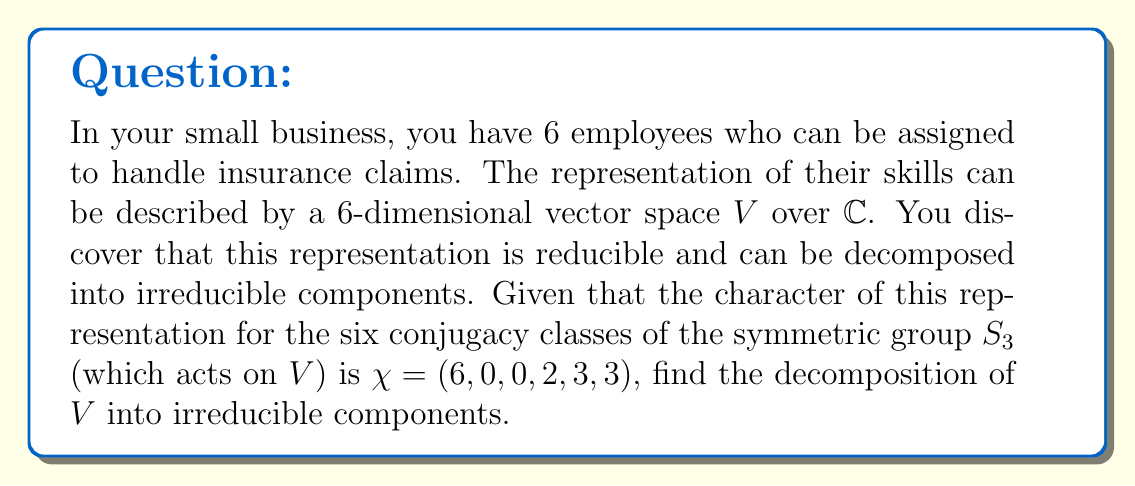Give your solution to this math problem. Let's approach this step-by-step:

1) First, recall that $S_3$ has three irreducible representations: the trivial representation ($\chi_1$), the sign representation ($\chi_2$), and a 2-dimensional representation ($\chi_3$). Their characters are:

   $\chi_1 = (1, 1, 1, 1, 1, 1)$
   $\chi_2 = (1, -1, -1, 1, 1, 1)$
   $\chi_3 = (2, 0, 0, -1, 1, 1)$

2) To find the decomposition, we need to calculate the multiplicities of each irreducible representation in $V$. We use the formula:

   $m_i = \frac{1}{|G|} \sum_{g \in G} \chi(g) \overline{\chi_i(g)}$

   where $|G| = 6$ for $S_3$.

3) For $\chi_1$:
   $m_1 = \frac{1}{6}(6 \cdot 1 + 0 \cdot 1 + 0 \cdot 1 + 2 \cdot 1 + 3 \cdot 1 + 3 \cdot 1) = \frac{14}{6} = \frac{7}{3}$

4) For $\chi_2$:
   $m_2 = \frac{1}{6}(6 \cdot 1 + 0 \cdot (-1) + 0 \cdot (-1) + 2 \cdot 1 + 3 \cdot 1 + 3 \cdot 1) = \frac{14}{6} = \frac{7}{3}$

5) For $\chi_3$:
   $m_3 = \frac{1}{6}(6 \cdot 2 + 0 \cdot 0 + 0 \cdot 0 + 2 \cdot (-1) + 3 \cdot 1 + 3 \cdot 1) = \frac{10}{6} = \frac{5}{3}$

6) The multiplicities must be integers, so we round to the nearest whole number:
   $m_1 = 2$, $m_2 = 2$, $m_3 = 2$

7) Therefore, the decomposition of $V$ is:

   $V \cong 2\chi_1 \oplus 2\chi_2 \oplus 2\chi_3$
Answer: $V \cong 2\chi_1 \oplus 2\chi_2 \oplus 2\chi_3$ 